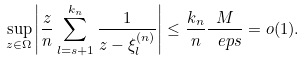<formula> <loc_0><loc_0><loc_500><loc_500>\sup _ { z \in \Omega } \left | \frac { z } { n } \sum _ { l = s + 1 } ^ { k _ { n } } \frac { 1 } { z - \xi _ { l } ^ { ( n ) } } \right | \leq \frac { k _ { n } } { n } \frac { M } { \ e p s } = o ( 1 ) .</formula> 